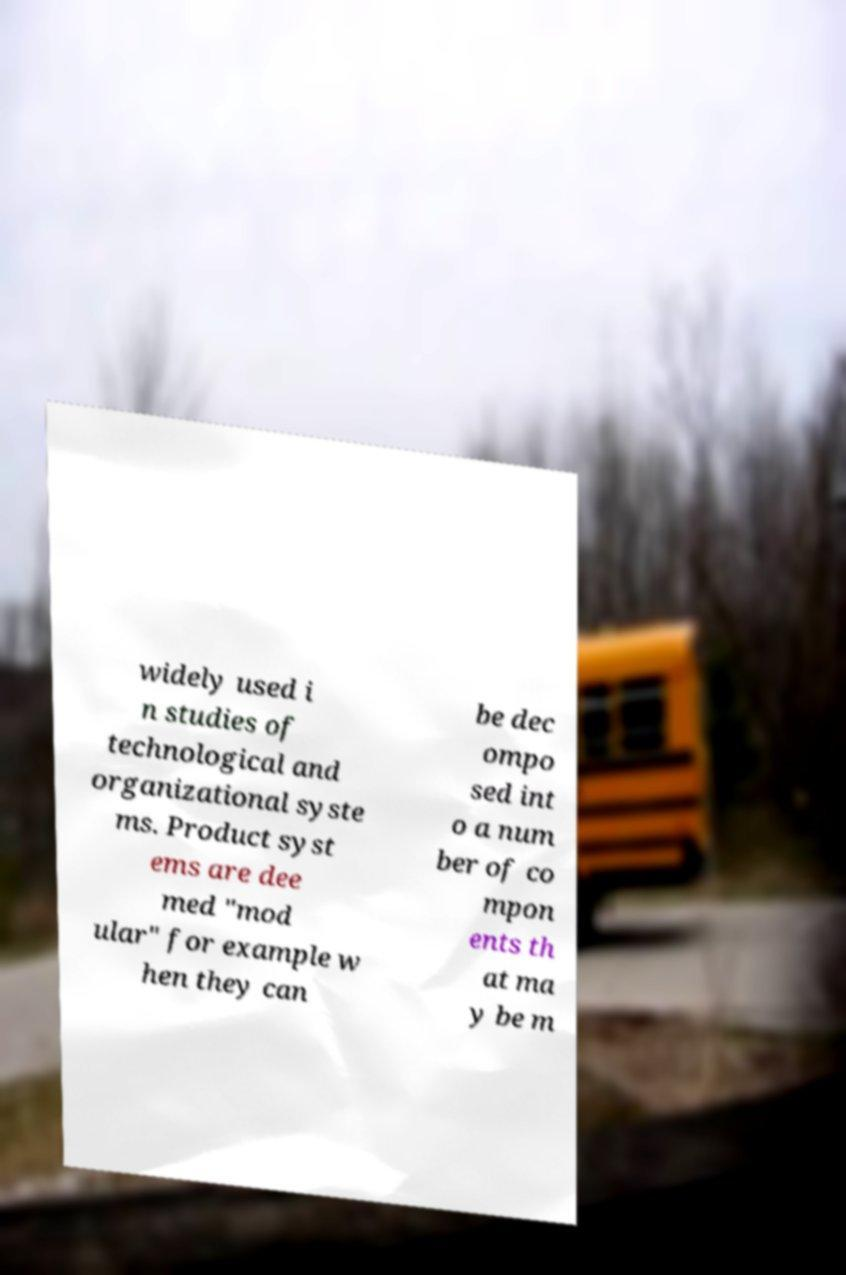Can you read and provide the text displayed in the image?This photo seems to have some interesting text. Can you extract and type it out for me? widely used i n studies of technological and organizational syste ms. Product syst ems are dee med "mod ular" for example w hen they can be dec ompo sed int o a num ber of co mpon ents th at ma y be m 